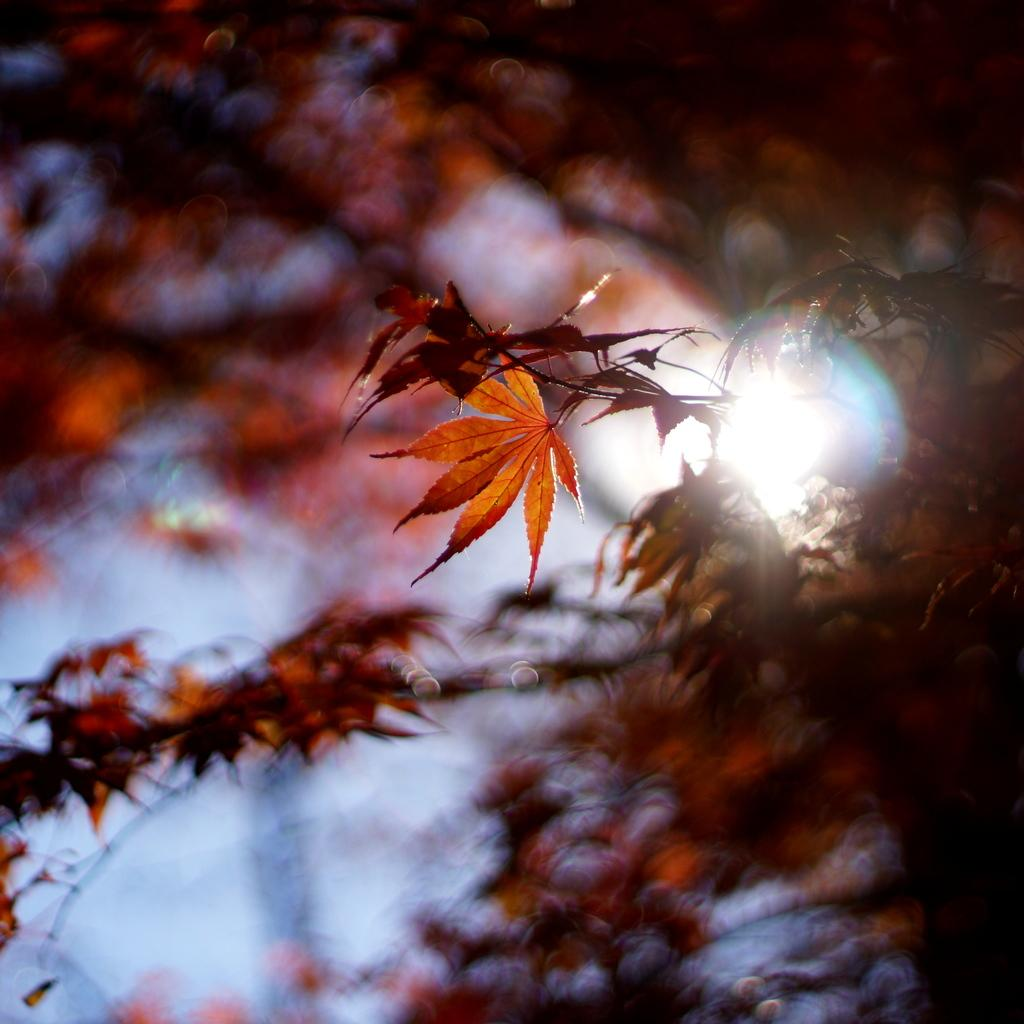What type of vegetation can be seen in the image? There are trees in the image. What part of the natural environment is visible in the image? The sky is visible in the image. How many bikes are parked under the trees in the image? There are no bikes present in the image; it only features trees and the sky. What type of veil is draped over the trees in the image? There is no veil present in the image; the trees are not covered or draped with any fabric. 